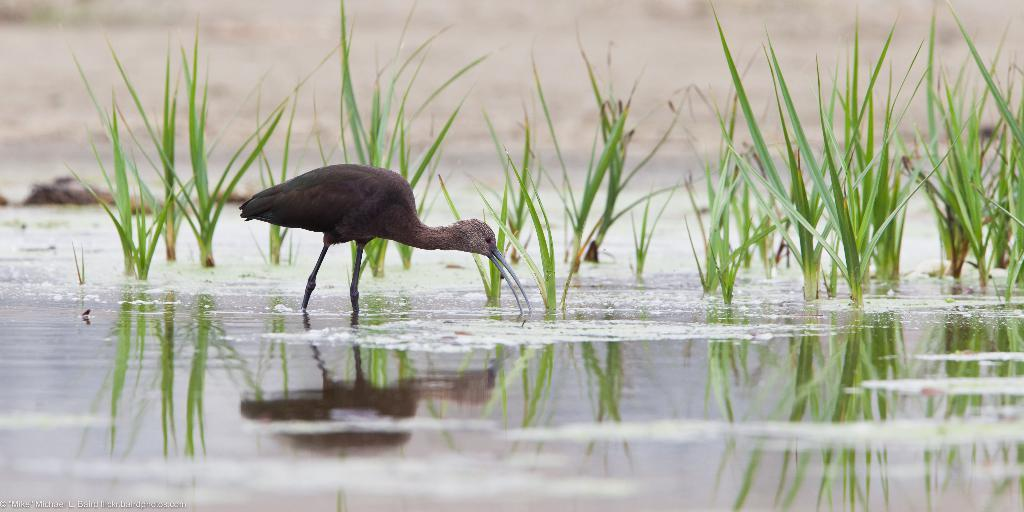What type of animal is in the image? There is an animal in the image, but the specific type cannot be determined from the provided facts. What can be seen in the image besides the animal? There are green plants and water visible in the image. What type of bait is being used to catch the animal in the image? There is no bait present in the image, as it only features an animal, green plants, and water. 